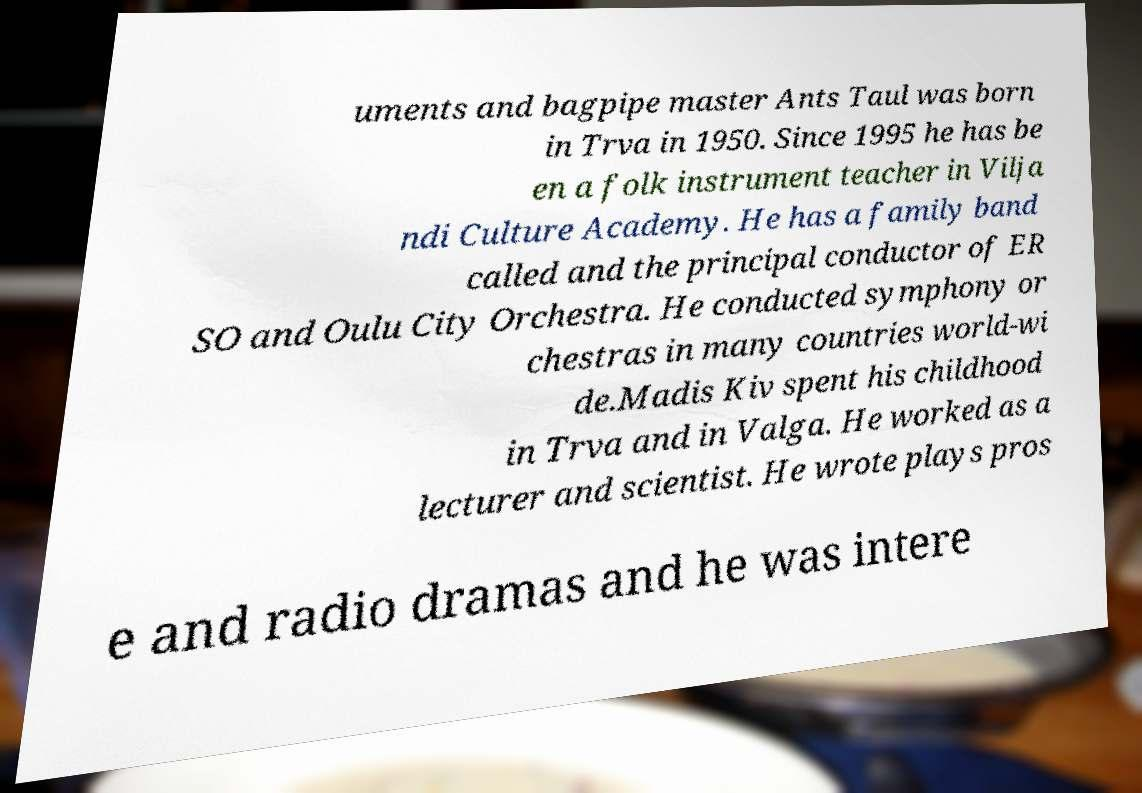Please read and relay the text visible in this image. What does it say? uments and bagpipe master Ants Taul was born in Trva in 1950. Since 1995 he has be en a folk instrument teacher in Vilja ndi Culture Academy. He has a family band called and the principal conductor of ER SO and Oulu City Orchestra. He conducted symphony or chestras in many countries world-wi de.Madis Kiv spent his childhood in Trva and in Valga. He worked as a lecturer and scientist. He wrote plays pros e and radio dramas and he was intere 